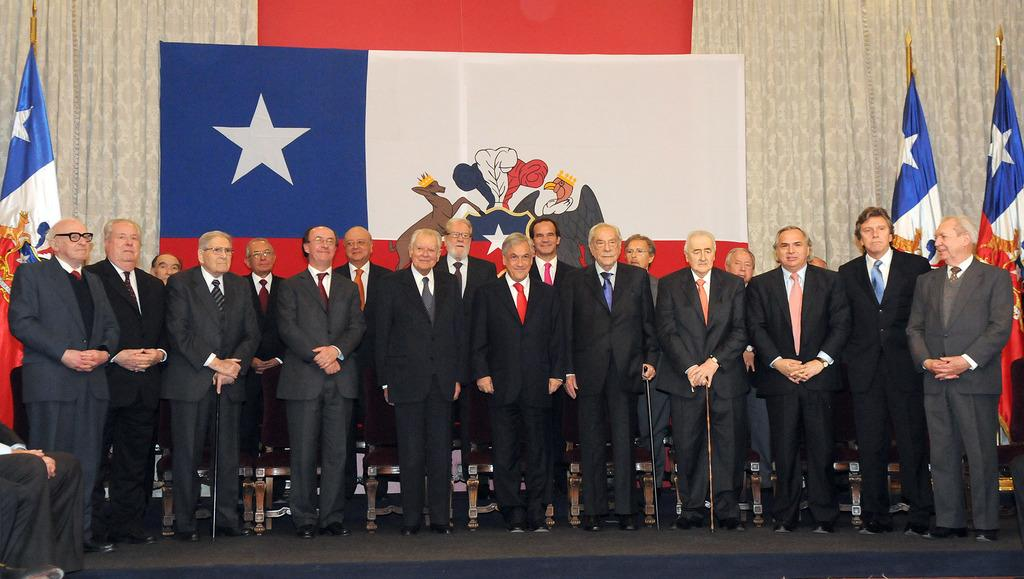What is the arrangement of the men in the image? The men are standing in series in the image. Where are the flags located in the image? There are flags on both the right and left sides of the image. What type of bottle can be seen in the shade in the image? There is no bottle or shade present in the image. 